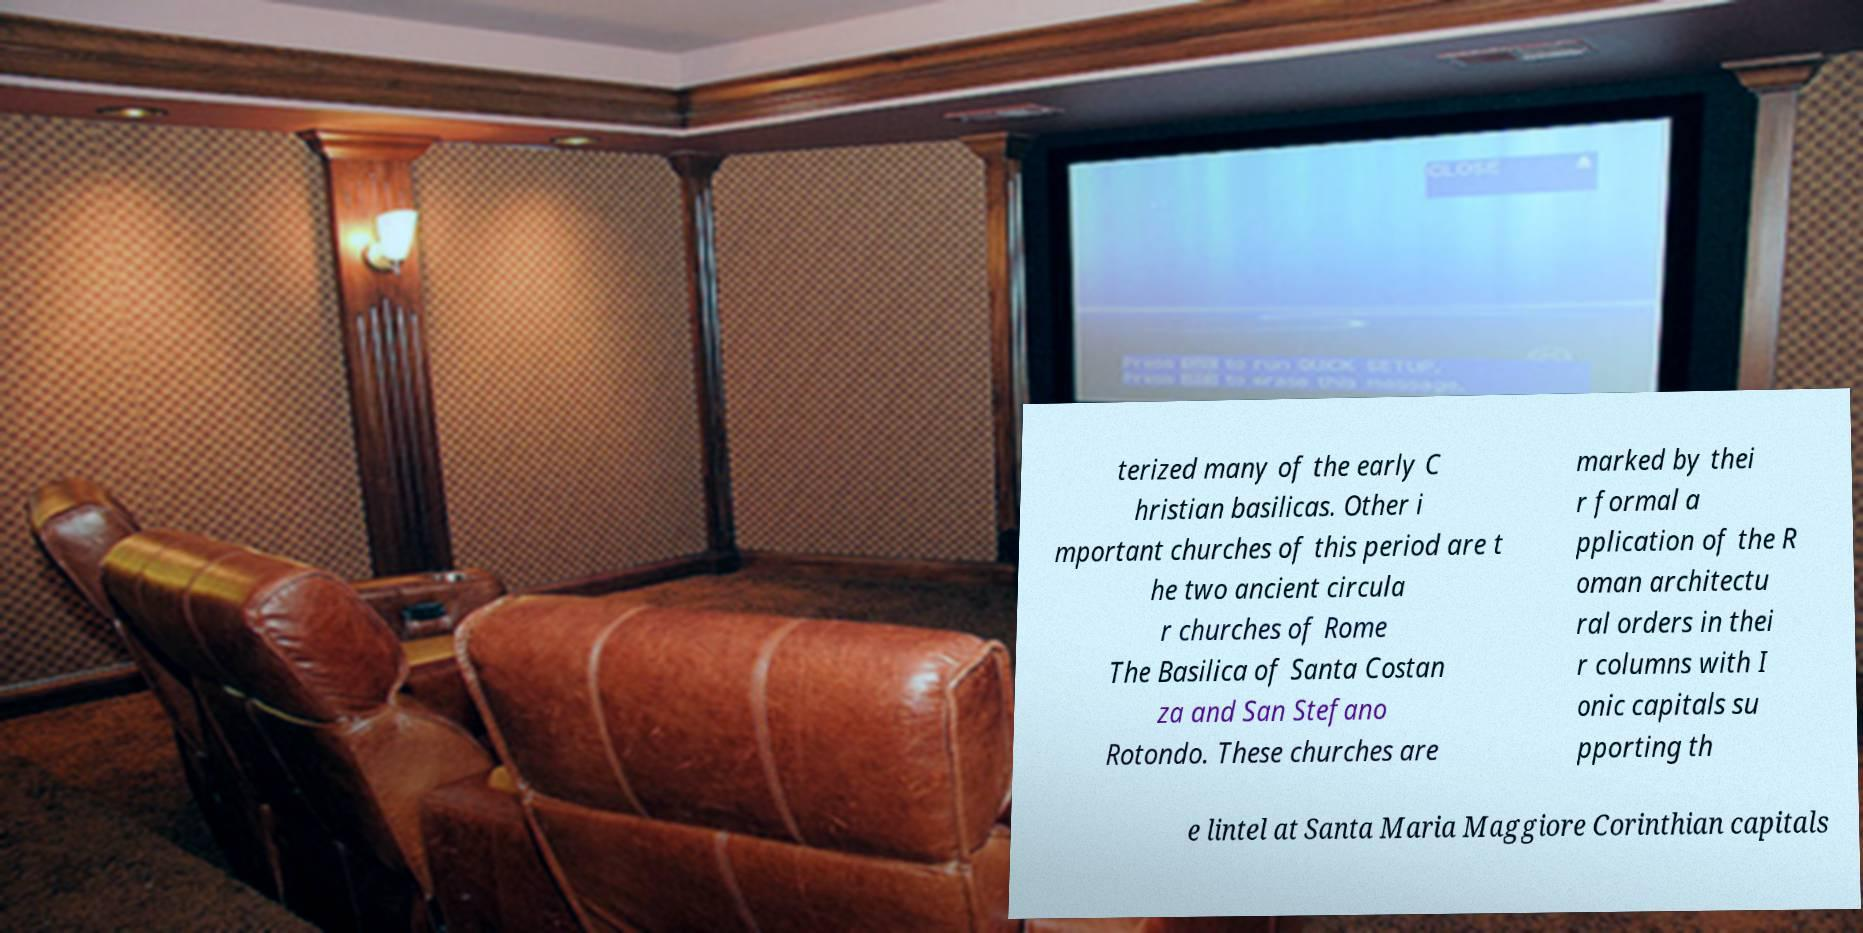Can you accurately transcribe the text from the provided image for me? terized many of the early C hristian basilicas. Other i mportant churches of this period are t he two ancient circula r churches of Rome The Basilica of Santa Costan za and San Stefano Rotondo. These churches are marked by thei r formal a pplication of the R oman architectu ral orders in thei r columns with I onic capitals su pporting th e lintel at Santa Maria Maggiore Corinthian capitals 